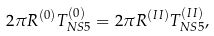<formula> <loc_0><loc_0><loc_500><loc_500>2 \pi R ^ { ( 0 ) } T ^ { ( 0 ) } _ { N S 5 } = 2 \pi R ^ { ( I I ) } T ^ { ( I I ) } _ { N S 5 } ,</formula> 